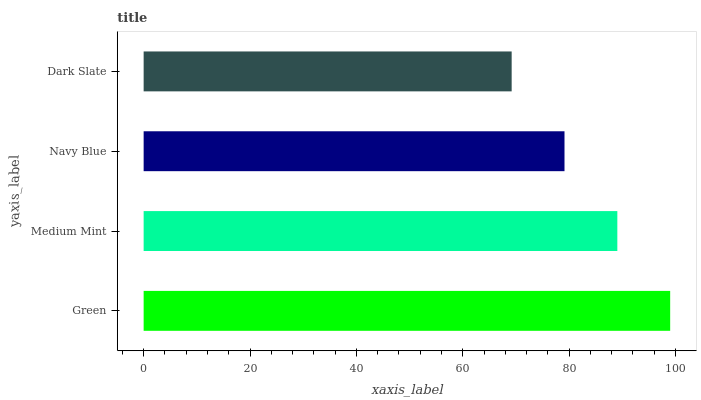Is Dark Slate the minimum?
Answer yes or no. Yes. Is Green the maximum?
Answer yes or no. Yes. Is Medium Mint the minimum?
Answer yes or no. No. Is Medium Mint the maximum?
Answer yes or no. No. Is Green greater than Medium Mint?
Answer yes or no. Yes. Is Medium Mint less than Green?
Answer yes or no. Yes. Is Medium Mint greater than Green?
Answer yes or no. No. Is Green less than Medium Mint?
Answer yes or no. No. Is Medium Mint the high median?
Answer yes or no. Yes. Is Navy Blue the low median?
Answer yes or no. Yes. Is Navy Blue the high median?
Answer yes or no. No. Is Green the low median?
Answer yes or no. No. 